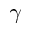<formula> <loc_0><loc_0><loc_500><loc_500>\gamma</formula> 